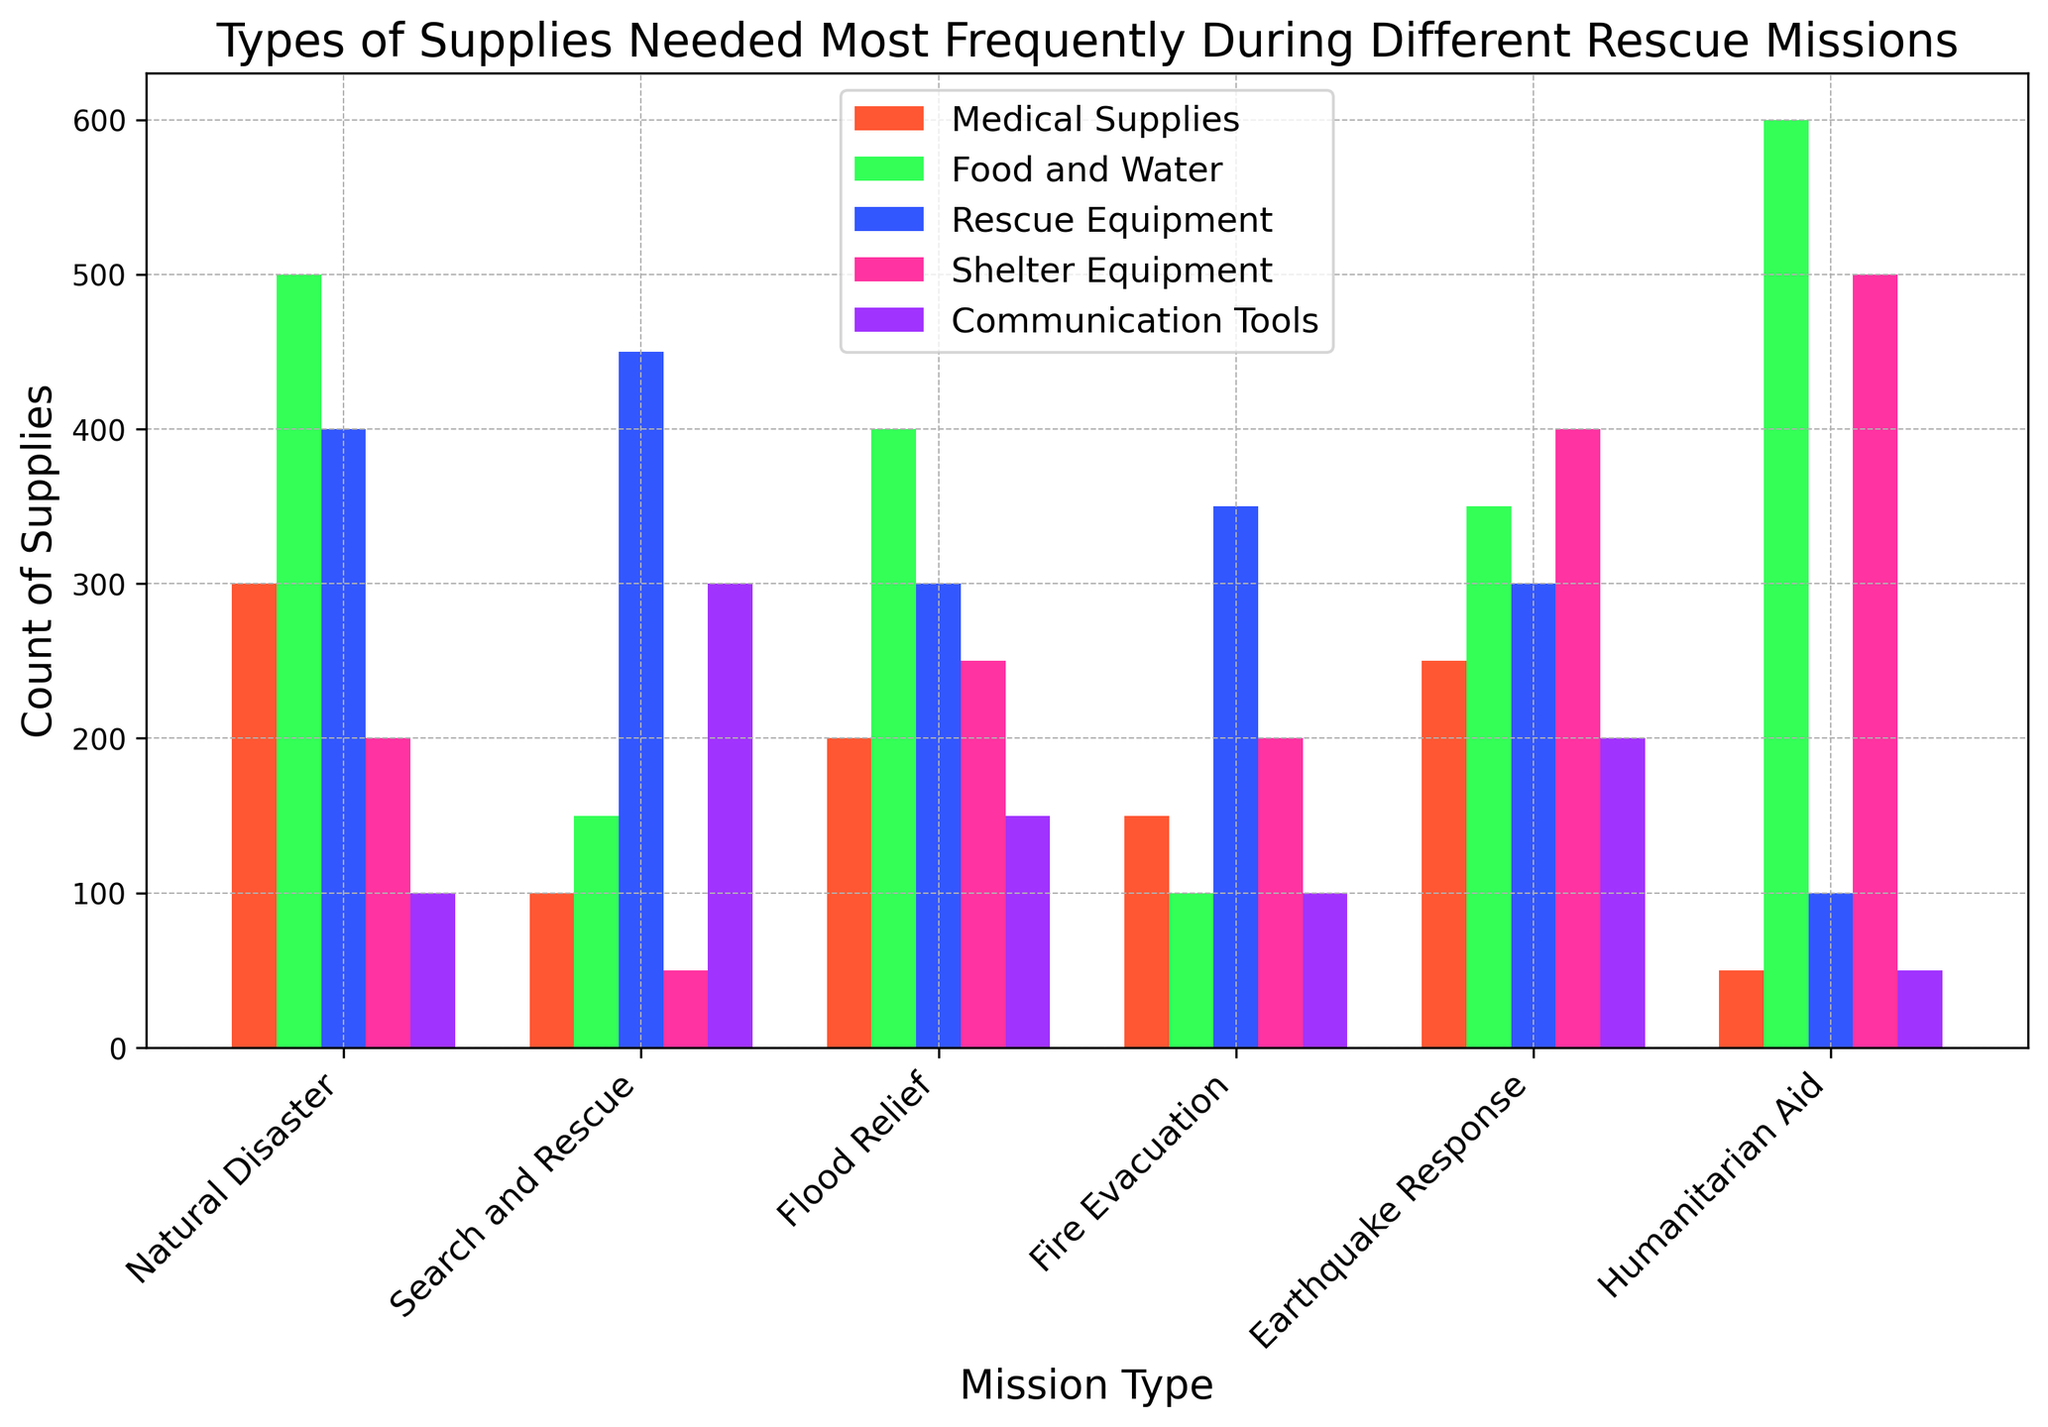Which mission type has the highest need for food and water? By looking at the bar heights corresponding to "Food and Water" across different mission types, the tallest bar can be identified. Humanitarian Aid has the highest bar for food and water.
Answer: Humanitarian Aid What is the most frequently needed supply type during fire evacuations? Among the supply types for "Fire Evacuation", the bar with the greatest height represents the most frequently needed supply. Rescue Equipment has the highest bar for Fire Evacuation.
Answer: Rescue Equipment Which mission type requires the most shelter equipment, and how do you know? For the "Shelter Equipment" category, compare the bars across different mission types. Earthquake Response has the tallest bar in this category.
Answer: Earthquake Response How do the needs for medical supplies differ between Natural Disaster and Earthquake Response missions? Compare the heights of the "Medical Supplies" bars for both Natural Disaster and Earthquake Response. Natural Disaster needs 300 medical supplies, while Earthquake Response needs 250.
Answer: Natural Disaster requires 50 more medical supplies Which mission type has the least need for communication tools, and by how much compared to the next lowest? Locate the shortest bar in the "Communication Tools" category, then find the second shortest bar. Humanitarian Aid has the lowest with 50, next lowest is Fire Evacuation with 100.
Answer: Humanitarian Aid needs 50 less If you combine the need for rescue equipment and medical supplies for flood relief missions, what is the total? Sum the values for "Rescue Equipment" and "Medical Supplies" in the Flood Relief mission type: 300 + 200 = 500.
Answer: 500 What is the ratio of the need for food and water to communication tools for search and rescue missions? Divide the "Food and Water" requirement by the "Communication Tools" requirement for Search and Rescue missions: 150 / 300 = 0.5.
Answer: 0.5 Which supply type has the least variation in need across all mission types? Compare the range (difference between the maximum and minimum values) of all supply types. "Communication Tools" ranges from 50 to 300, which is less varied compared to others.
Answer: Communication Tools On average, how many rescue equipment supplies are needed across all mission types? Add the values for "Rescue Equipment" across all missions and divide by the number of mission types: (400 + 450 + 300 + 350 + 300 + 100) / 6 = 316.67.
Answer: 316.67 